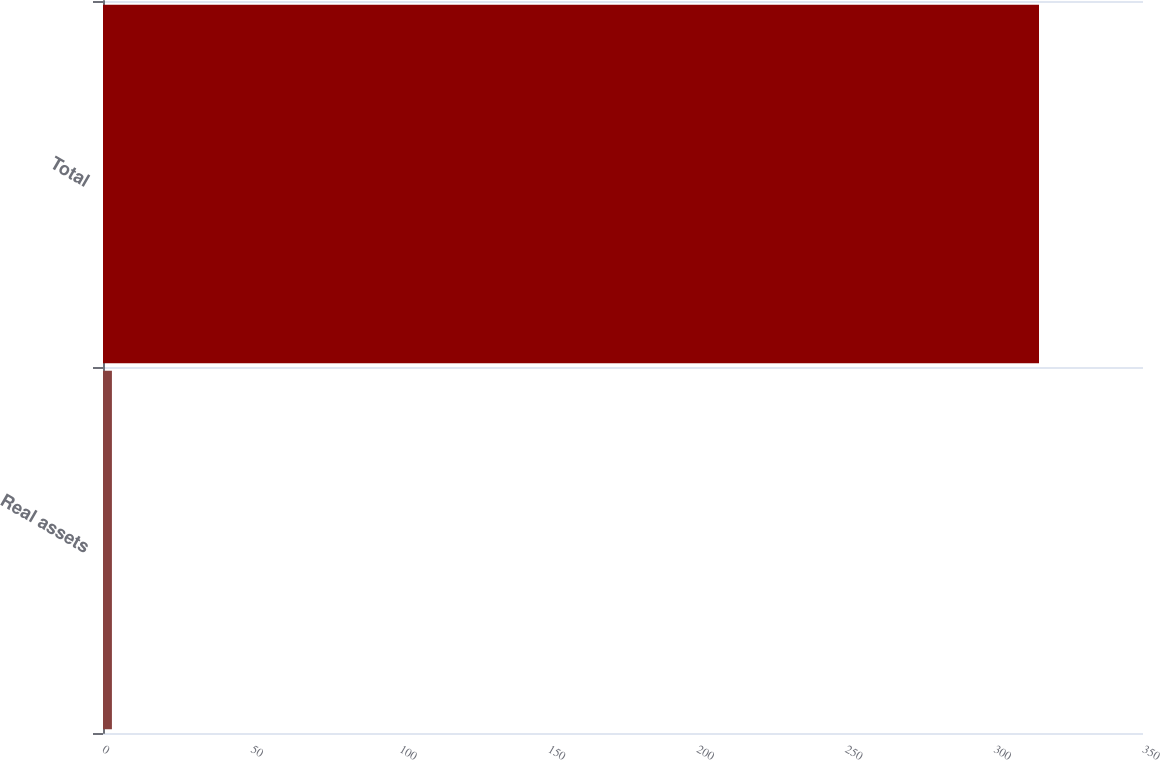Convert chart. <chart><loc_0><loc_0><loc_500><loc_500><bar_chart><fcel>Real assets<fcel>Total<nl><fcel>3<fcel>315<nl></chart> 